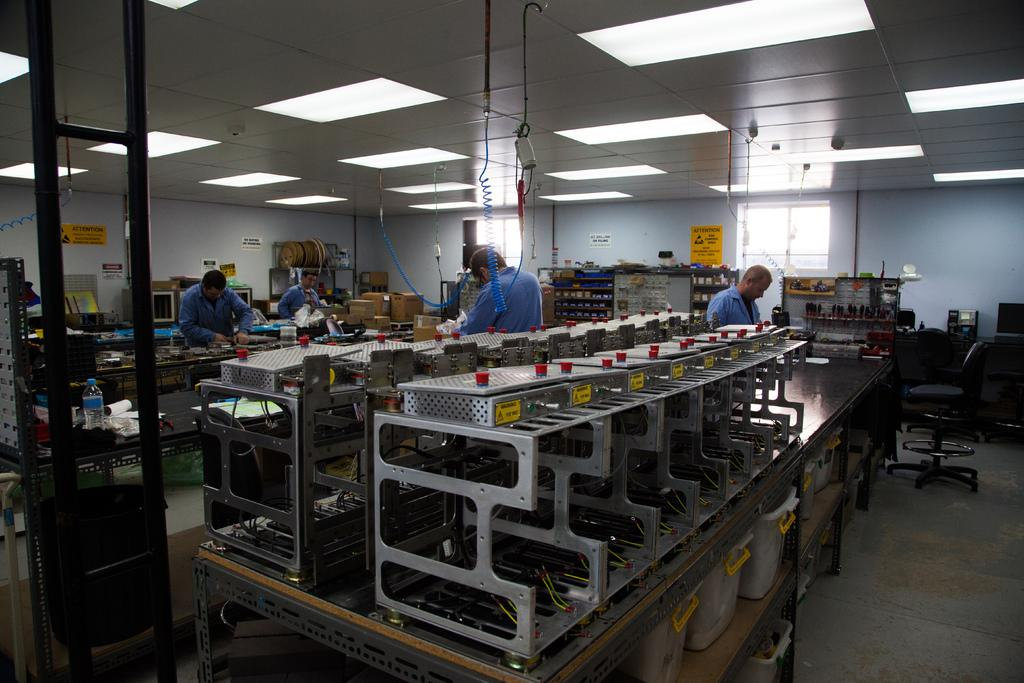What is happening in the image? There are people standing in the image. What type of equipment can be seen in the room? There is machinery in the room. What can be seen through the windows in the image? There are windows in the image. What is providing illumination in the room? There are lights in the ceiling. What is visible in the background of the image? There is a wall in the background of the image. What type of stone is being used to make the statement on the wall? There is no statement or stone present on the wall in the image. 